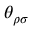<formula> <loc_0><loc_0><loc_500><loc_500>\theta _ { \rho \sigma }</formula> 